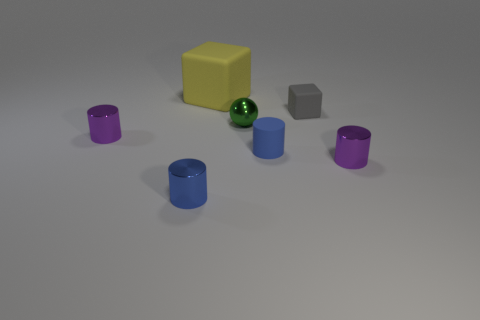Add 1 tiny matte things. How many objects exist? 8 Subtract all cubes. How many objects are left? 5 Subtract 1 spheres. How many spheres are left? 0 Subtract all brown cylinders. Subtract all green cubes. How many cylinders are left? 4 Subtract all cyan cylinders. How many gray cubes are left? 1 Subtract all small blue shiny objects. Subtract all rubber cylinders. How many objects are left? 5 Add 2 small metal objects. How many small metal objects are left? 6 Add 4 large brown matte cylinders. How many large brown matte cylinders exist? 4 Subtract all gray blocks. How many blocks are left? 1 Subtract all rubber cylinders. How many cylinders are left? 3 